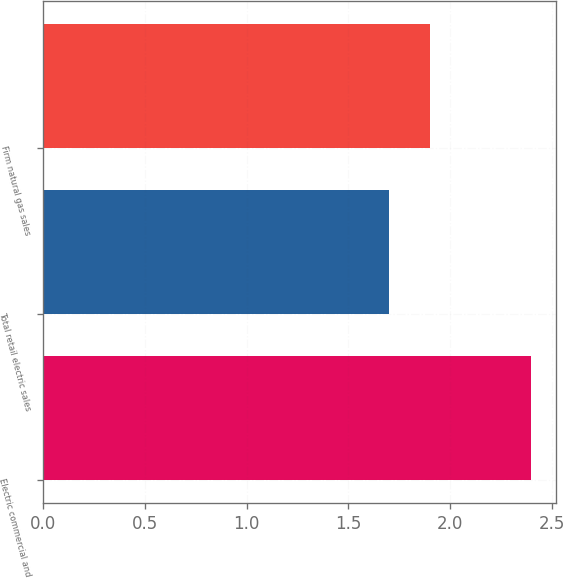Convert chart. <chart><loc_0><loc_0><loc_500><loc_500><bar_chart><fcel>Electric commercial and<fcel>Total retail electric sales<fcel>Firm natural gas sales<nl><fcel>2.4<fcel>1.7<fcel>1.9<nl></chart> 